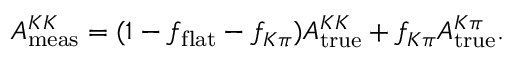Convert formula to latex. <formula><loc_0><loc_0><loc_500><loc_500>A _ { m e a s } ^ { K K } = ( 1 - f _ { f l a t } - f _ { K \pi } ) A _ { t r u e } ^ { K K } + f _ { K \pi } A _ { t r u e } ^ { K \pi } .</formula> 